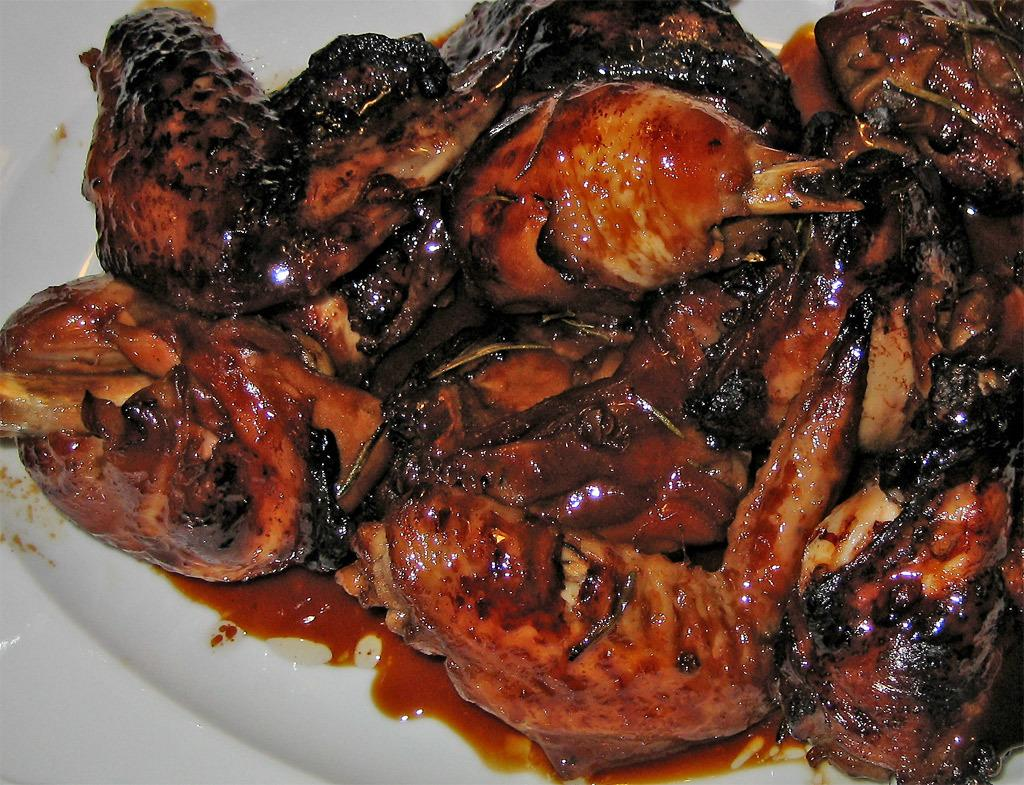What can be seen on the plate in the image? There is a food item on the plate in the image. Can you describe the plate itself? The facts provided do not give any information about the plate's appearance or material. What type of texture does the orange have in the image? There is no orange present in the image. 